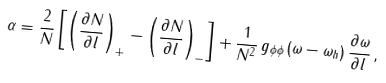<formula> <loc_0><loc_0><loc_500><loc_500>\alpha = \frac { 2 } { N } \left [ \left ( \frac { \partial N } { \partial l } \right ) _ { + } - \left ( \frac { \partial N } { \partial l } \right ) _ { - } \right ] + \frac { 1 } { N ^ { 2 } } \, g _ { \phi \phi } \, ( \omega - \omega _ { h } ) \, \frac { \partial \omega } { \partial l } \, ,</formula> 